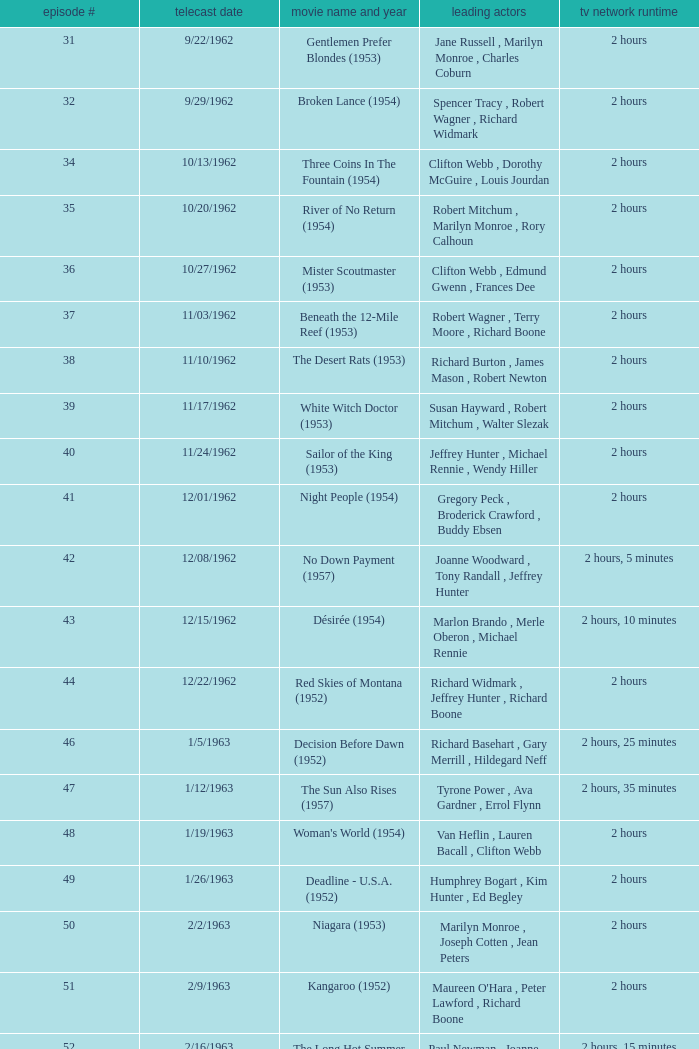Who was the cast on the 3/23/1963 episode? Dana Wynter , Mel Ferrer , Theodore Bikel. 